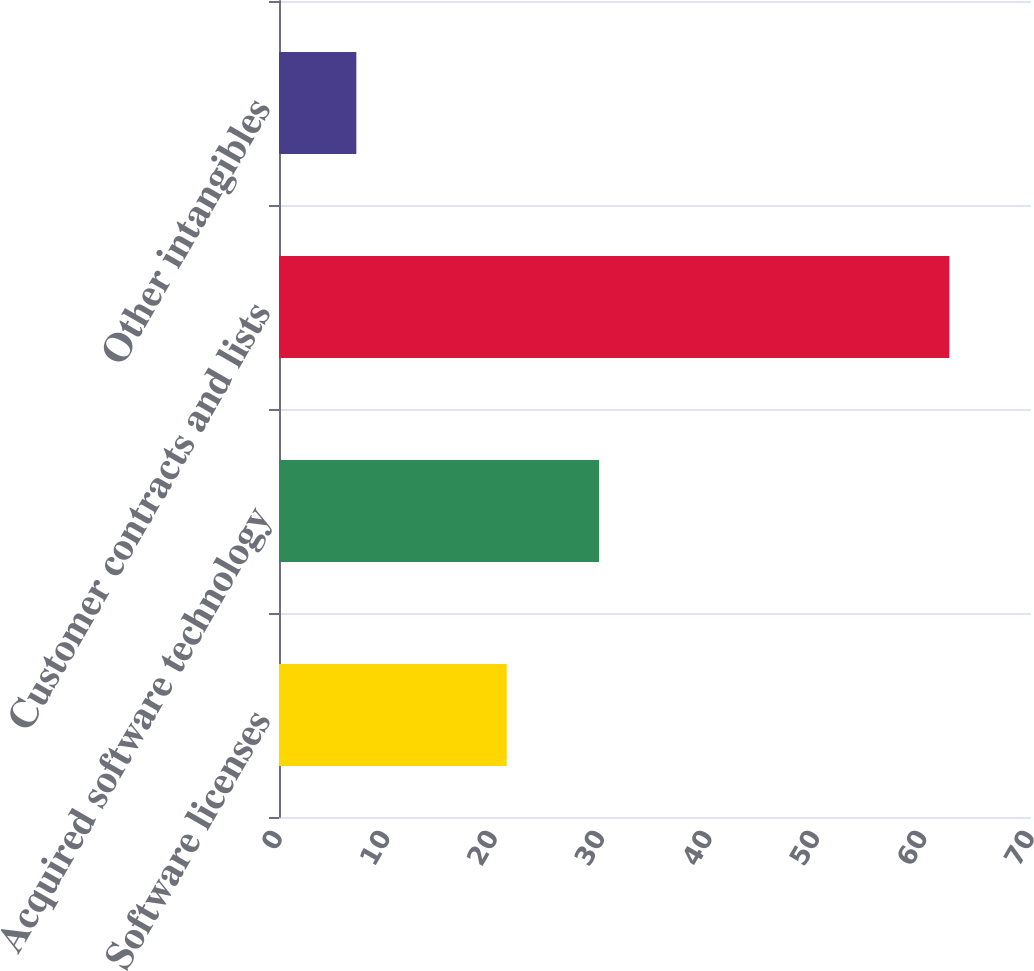<chart> <loc_0><loc_0><loc_500><loc_500><bar_chart><fcel>Software licenses<fcel>Acquired software technology<fcel>Customer contracts and lists<fcel>Other intangibles<nl><fcel>21.2<fcel>29.8<fcel>62.4<fcel>7.2<nl></chart> 